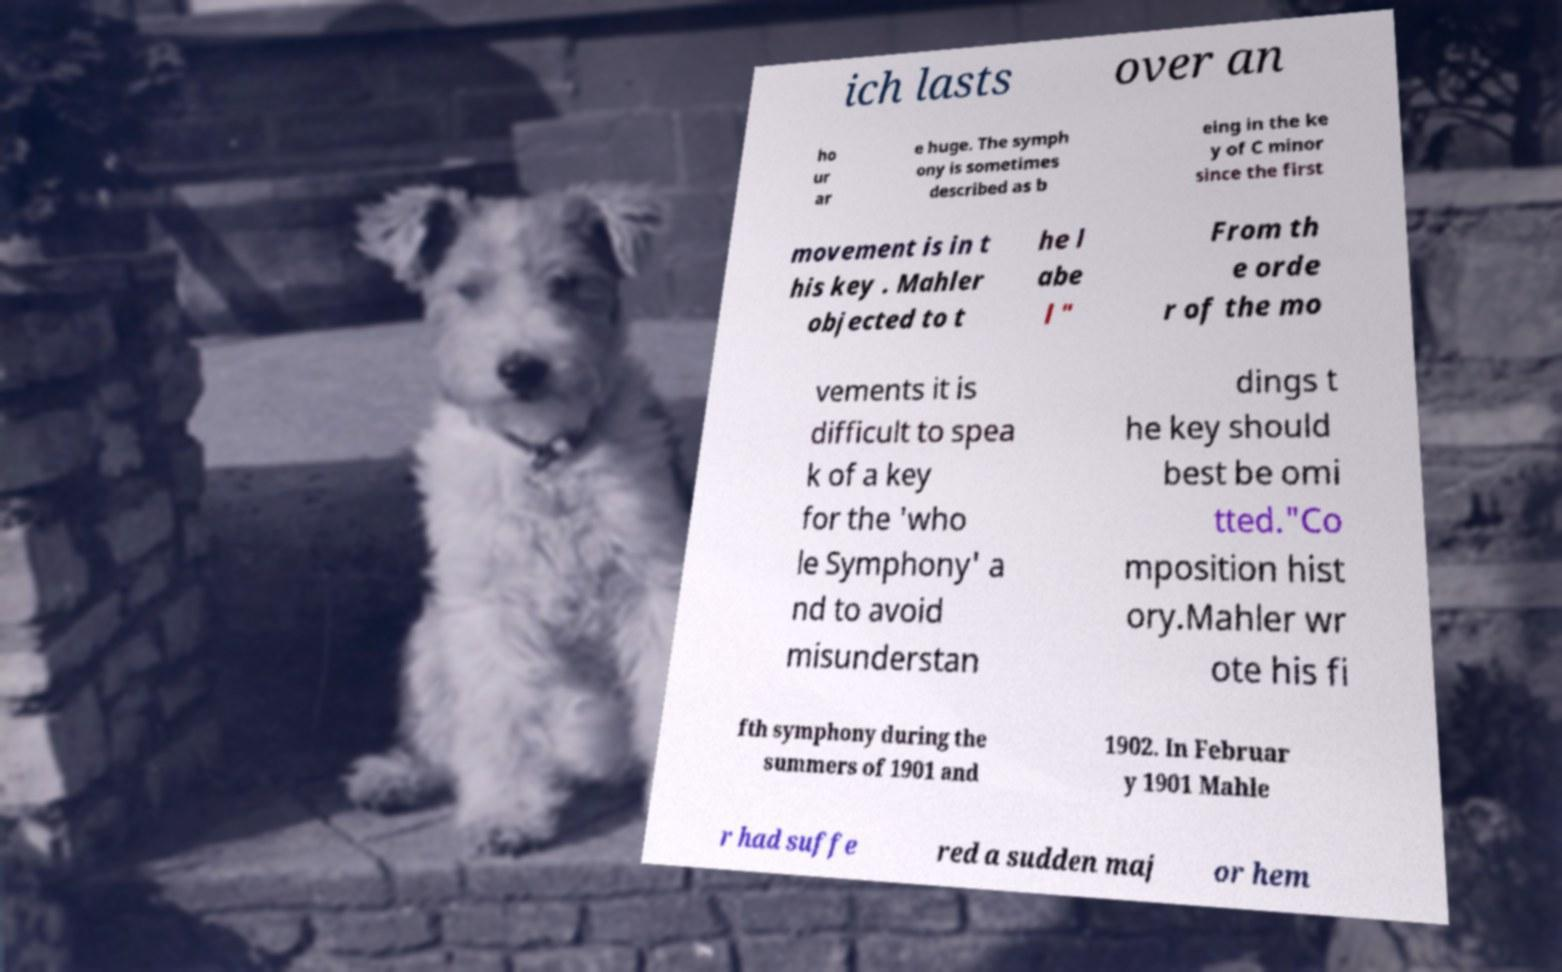Could you assist in decoding the text presented in this image and type it out clearly? ich lasts over an ho ur ar e huge. The symph ony is sometimes described as b eing in the ke y of C minor since the first movement is in t his key . Mahler objected to t he l abe l " From th e orde r of the mo vements it is difficult to spea k of a key for the 'who le Symphony' a nd to avoid misunderstan dings t he key should best be omi tted."Co mposition hist ory.Mahler wr ote his fi fth symphony during the summers of 1901 and 1902. In Februar y 1901 Mahle r had suffe red a sudden maj or hem 